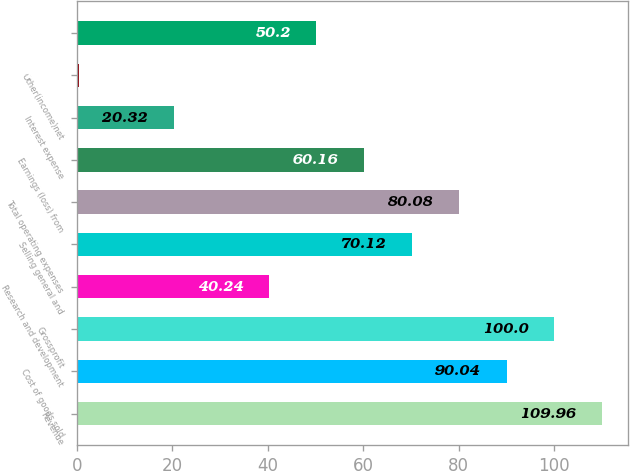<chart> <loc_0><loc_0><loc_500><loc_500><bar_chart><fcel>Revenue<fcel>Cost of goods sold<fcel>Grossprofit<fcel>Research and development<fcel>Selling general and<fcel>Total operating expenses<fcel>Earnings (loss) from<fcel>Interest expense<fcel>Other(income)net<fcel>Unnamed: 9<nl><fcel>109.96<fcel>90.04<fcel>100<fcel>40.24<fcel>70.12<fcel>80.08<fcel>60.16<fcel>20.32<fcel>0.4<fcel>50.2<nl></chart> 